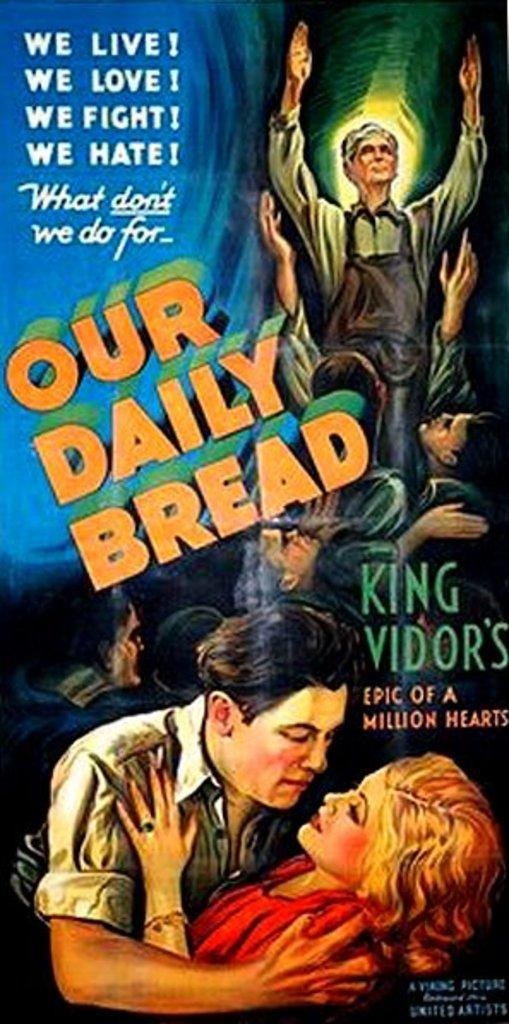<image>
Create a compact narrative representing the image presented. Poster that says Our Daily Bread Epic of a Million Hearts. 